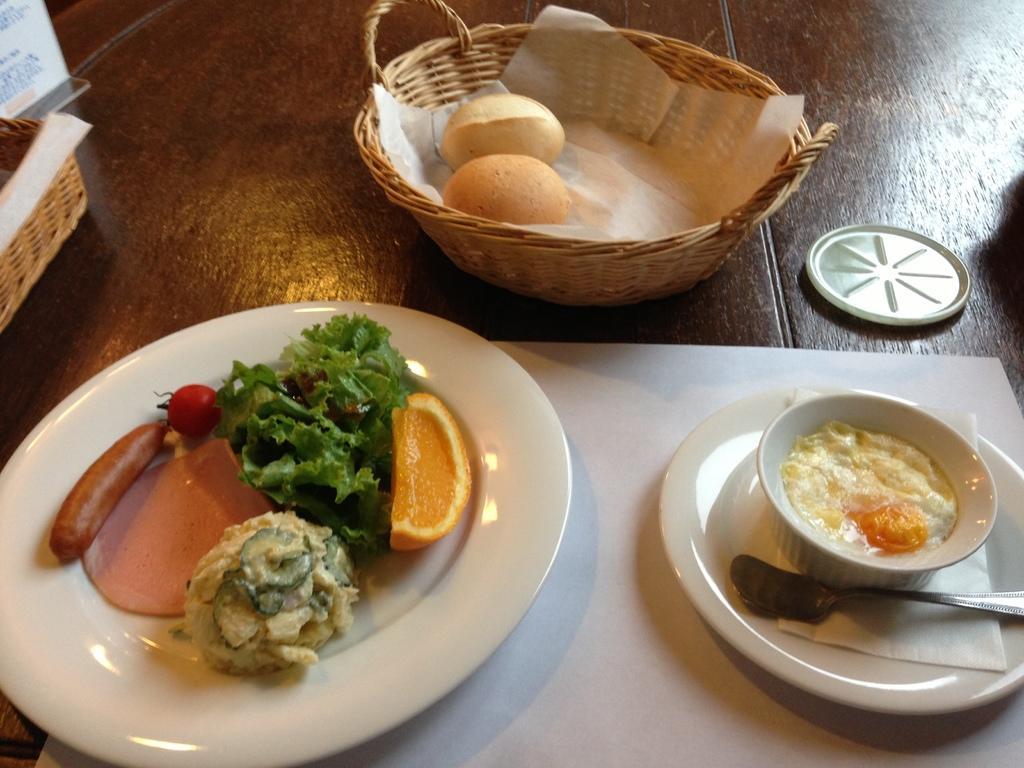Can you describe this image briefly? In this image, I can see the food items on a plate, bowl and a basket, there is a lid and few other things are placed on a wooden table. 